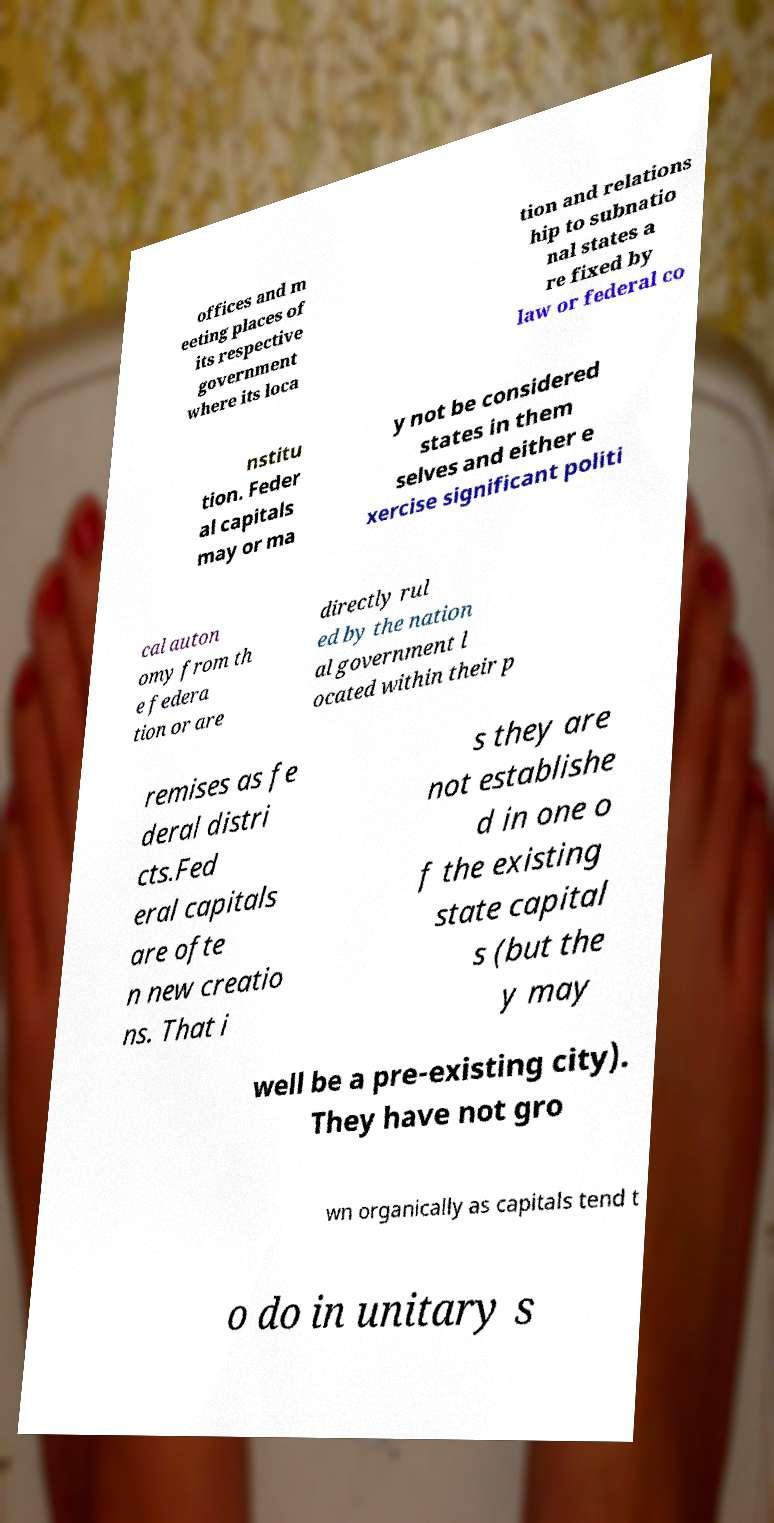I need the written content from this picture converted into text. Can you do that? offices and m eeting places of its respective government where its loca tion and relations hip to subnatio nal states a re fixed by law or federal co nstitu tion. Feder al capitals may or ma y not be considered states in them selves and either e xercise significant politi cal auton omy from th e federa tion or are directly rul ed by the nation al government l ocated within their p remises as fe deral distri cts.Fed eral capitals are ofte n new creatio ns. That i s they are not establishe d in one o f the existing state capital s (but the y may well be a pre-existing city). They have not gro wn organically as capitals tend t o do in unitary s 